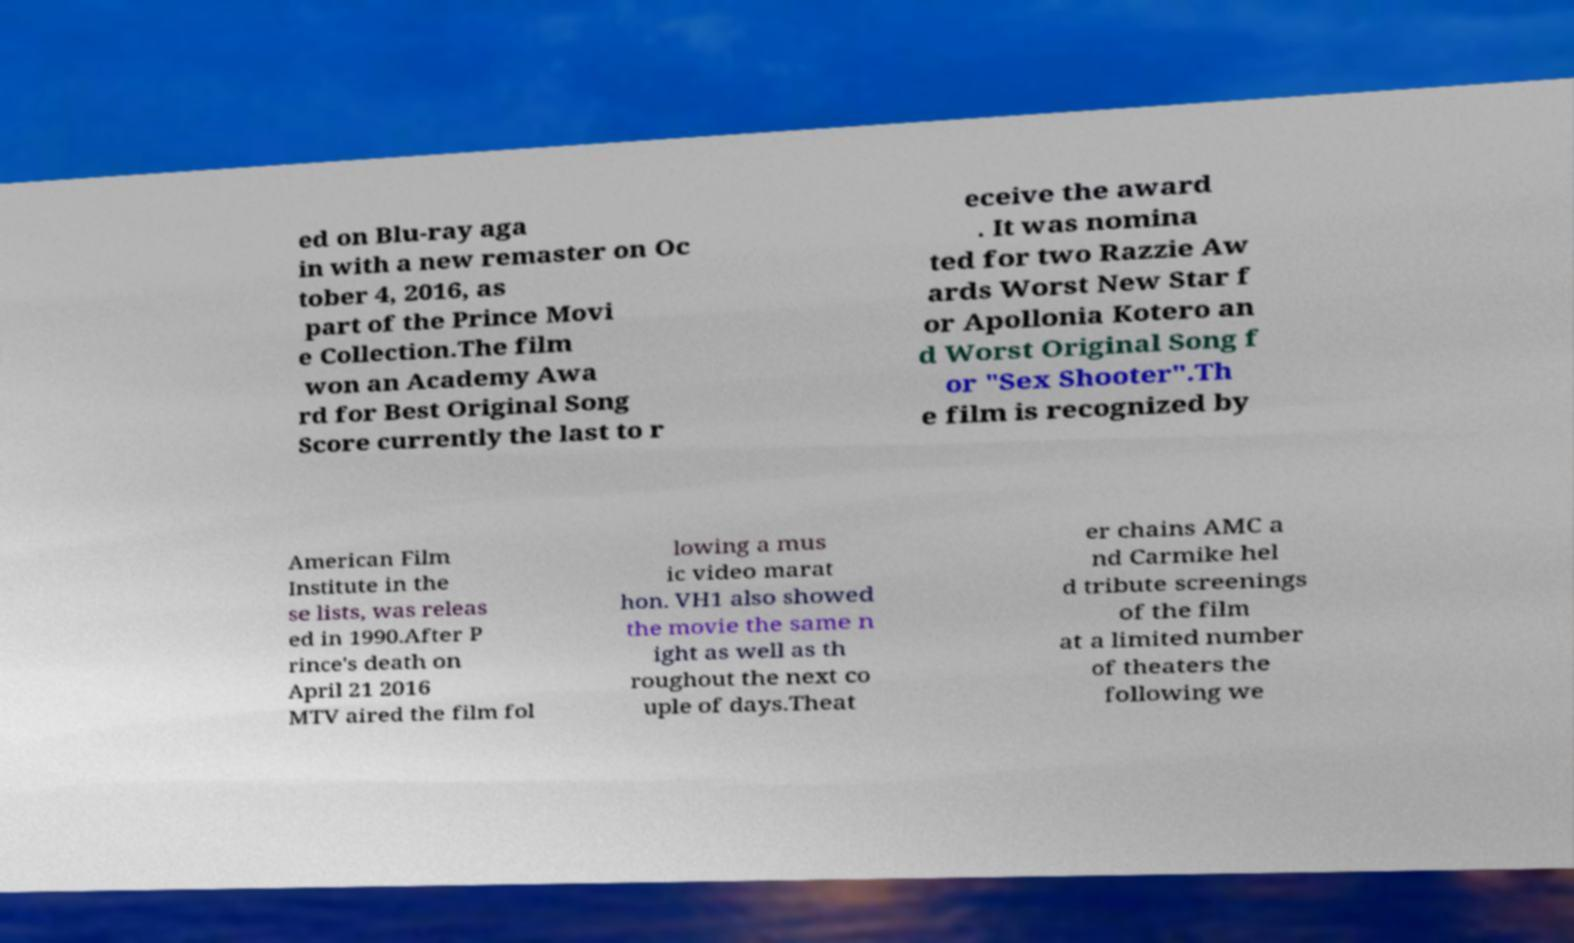Could you assist in decoding the text presented in this image and type it out clearly? ed on Blu-ray aga in with a new remaster on Oc tober 4, 2016, as part of the Prince Movi e Collection.The film won an Academy Awa rd for Best Original Song Score currently the last to r eceive the award . It was nomina ted for two Razzie Aw ards Worst New Star f or Apollonia Kotero an d Worst Original Song f or "Sex Shooter".Th e film is recognized by American Film Institute in the se lists, was releas ed in 1990.After P rince's death on April 21 2016 MTV aired the film fol lowing a mus ic video marat hon. VH1 also showed the movie the same n ight as well as th roughout the next co uple of days.Theat er chains AMC a nd Carmike hel d tribute screenings of the film at a limited number of theaters the following we 